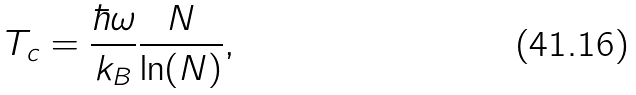Convert formula to latex. <formula><loc_0><loc_0><loc_500><loc_500>T _ { c } = \frac { \hbar { \omega } } { k _ { B } } \frac { N } { \ln ( N ) } ,</formula> 